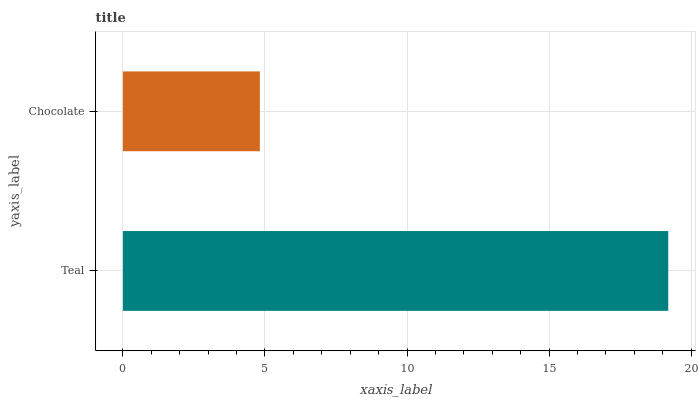Is Chocolate the minimum?
Answer yes or no. Yes. Is Teal the maximum?
Answer yes or no. Yes. Is Chocolate the maximum?
Answer yes or no. No. Is Teal greater than Chocolate?
Answer yes or no. Yes. Is Chocolate less than Teal?
Answer yes or no. Yes. Is Chocolate greater than Teal?
Answer yes or no. No. Is Teal less than Chocolate?
Answer yes or no. No. Is Teal the high median?
Answer yes or no. Yes. Is Chocolate the low median?
Answer yes or no. Yes. Is Chocolate the high median?
Answer yes or no. No. Is Teal the low median?
Answer yes or no. No. 